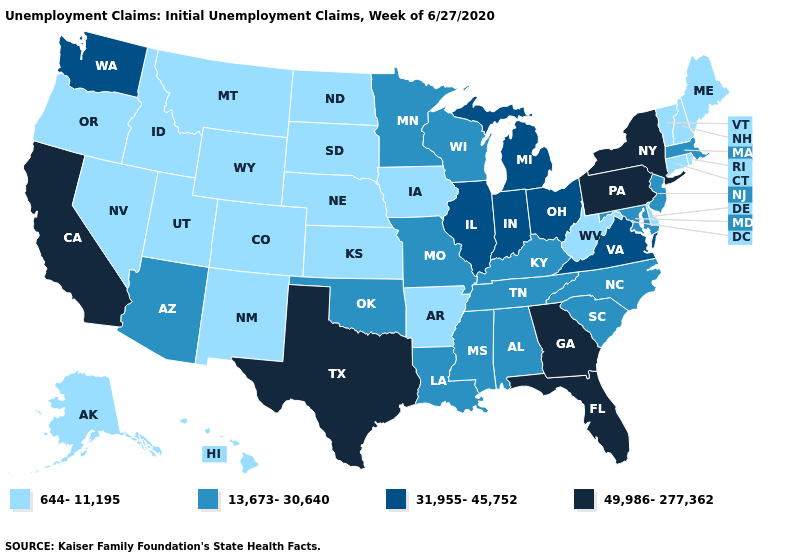How many symbols are there in the legend?
Concise answer only. 4. Does Washington have the lowest value in the West?
Keep it brief. No. Which states have the lowest value in the South?
Keep it brief. Arkansas, Delaware, West Virginia. Which states hav the highest value in the West?
Be succinct. California. What is the value of Oregon?
Give a very brief answer. 644-11,195. Does Montana have a higher value than Oregon?
Write a very short answer. No. Among the states that border Arizona , which have the highest value?
Concise answer only. California. How many symbols are there in the legend?
Be succinct. 4. Name the states that have a value in the range 31,955-45,752?
Be succinct. Illinois, Indiana, Michigan, Ohio, Virginia, Washington. Among the states that border South Dakota , which have the highest value?
Give a very brief answer. Minnesota. Which states have the lowest value in the West?
Answer briefly. Alaska, Colorado, Hawaii, Idaho, Montana, Nevada, New Mexico, Oregon, Utah, Wyoming. What is the highest value in the USA?
Concise answer only. 49,986-277,362. What is the lowest value in states that border New York?
Answer briefly. 644-11,195. What is the highest value in the USA?
Give a very brief answer. 49,986-277,362. What is the value of New Hampshire?
Short answer required. 644-11,195. 